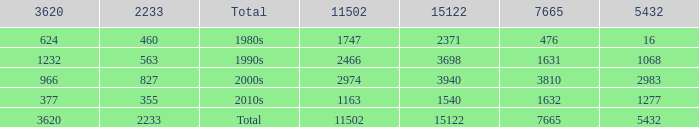What is the average 3620 value that has a 5432 of 1277 and a 15122 less than 1540? None. 